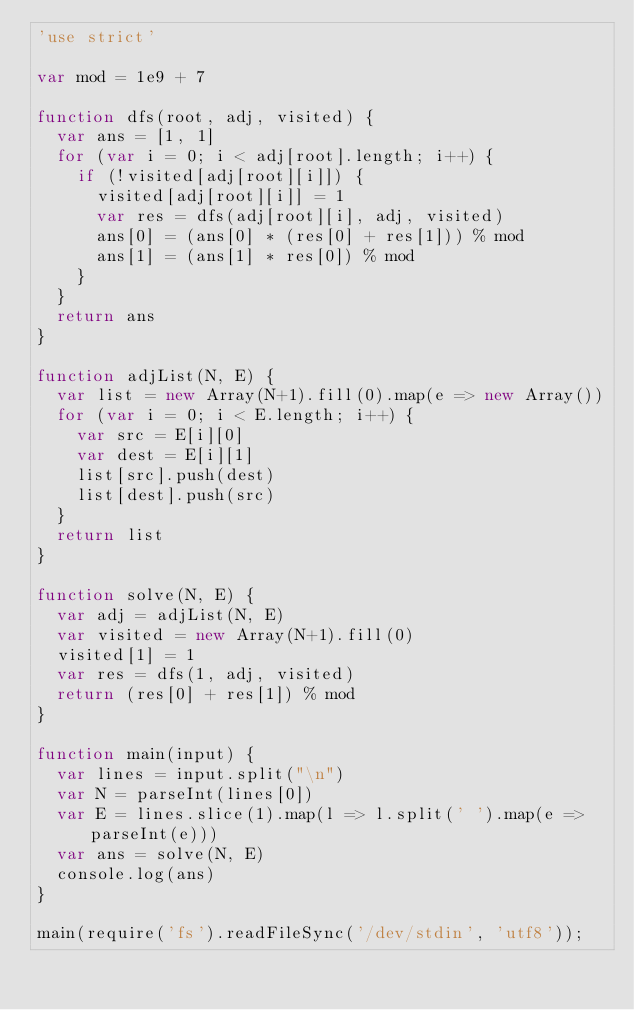<code> <loc_0><loc_0><loc_500><loc_500><_JavaScript_>'use strict'

var mod = 1e9 + 7

function dfs(root, adj, visited) {
  var ans = [1, 1]
  for (var i = 0; i < adj[root].length; i++) {
    if (!visited[adj[root][i]]) {
      visited[adj[root][i]] = 1
      var res = dfs(adj[root][i], adj, visited)
      ans[0] = (ans[0] * (res[0] + res[1])) % mod
      ans[1] = (ans[1] * res[0]) % mod
    }
  }
  return ans
}

function adjList(N, E) {
  var list = new Array(N+1).fill(0).map(e => new Array())
  for (var i = 0; i < E.length; i++) {
    var src = E[i][0]
    var dest = E[i][1]
    list[src].push(dest)
    list[dest].push(src)
  }
  return list
}

function solve(N, E) {
  var adj = adjList(N, E)
  var visited = new Array(N+1).fill(0)
  visited[1] = 1
  var res = dfs(1, adj, visited)
  return (res[0] + res[1]) % mod
}

function main(input) {
  var lines = input.split("\n")
  var N = parseInt(lines[0])
  var E = lines.slice(1).map(l => l.split(' ').map(e => parseInt(e)))
  var ans = solve(N, E)
  console.log(ans)
}

main(require('fs').readFileSync('/dev/stdin', 'utf8'));
</code> 